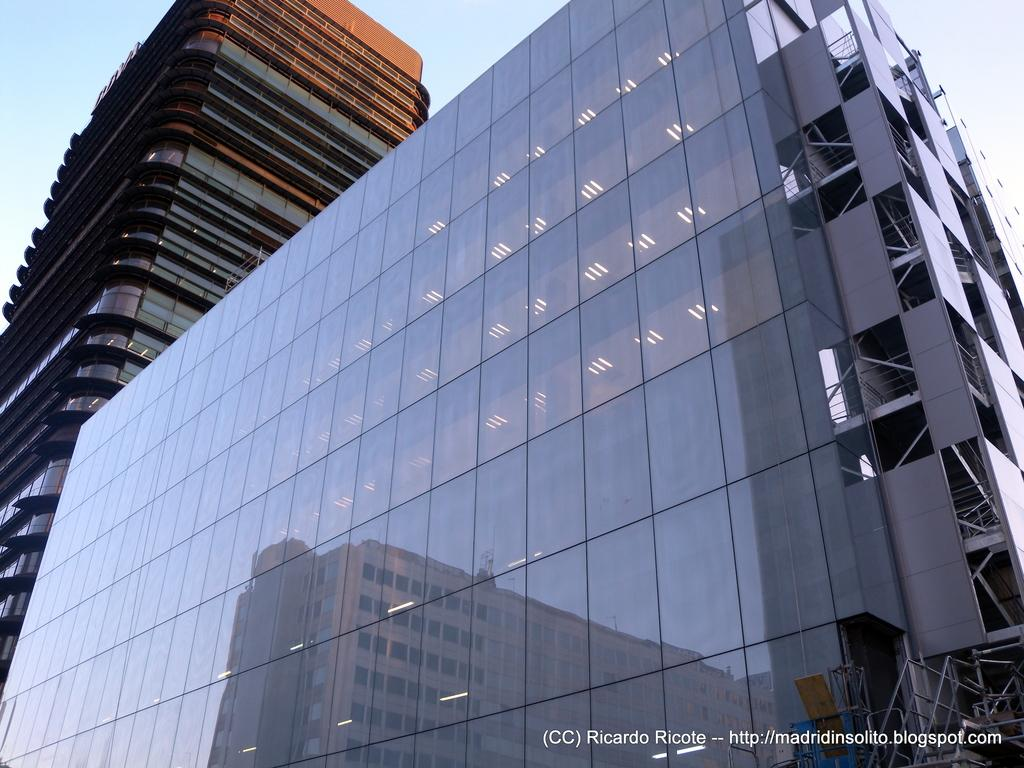How many buildings can be seen in the image? There are two buildings in the image. What is a unique feature of one of the buildings in the image? One building has a reflection of another building on its surface. What can be seen in the background of the image? The sky is visible in the background of the image. What type of cherry is being recited in the image? There is no cherry or verse present in the image; it only features two buildings and the sky. 